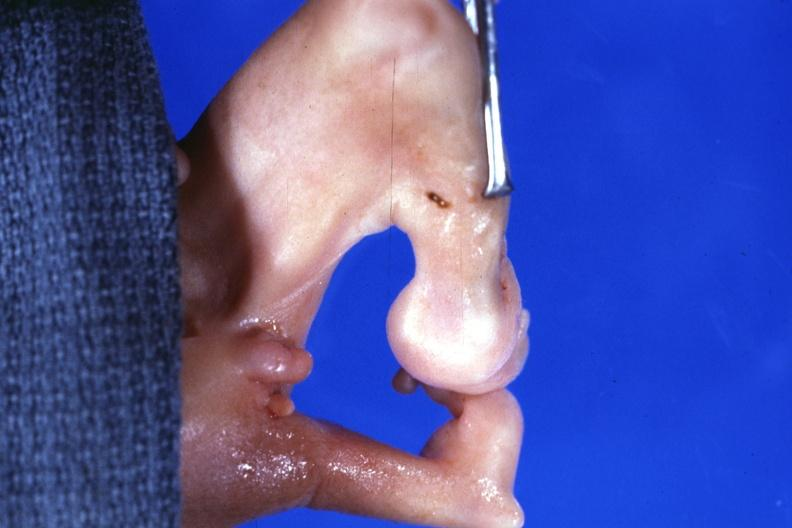what shows marked deformity both legs?
Answer the question using a single word or phrase. No 